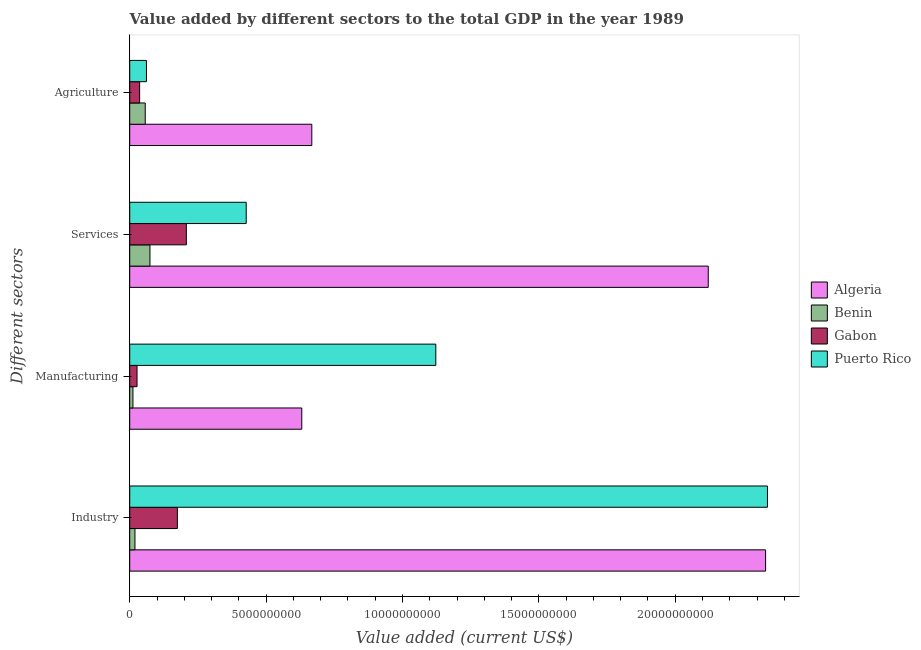How many groups of bars are there?
Your response must be concise. 4. Are the number of bars on each tick of the Y-axis equal?
Offer a terse response. Yes. How many bars are there on the 3rd tick from the top?
Your response must be concise. 4. How many bars are there on the 3rd tick from the bottom?
Keep it short and to the point. 4. What is the label of the 3rd group of bars from the top?
Make the answer very short. Manufacturing. What is the value added by manufacturing sector in Benin?
Make the answer very short. 1.18e+08. Across all countries, what is the maximum value added by industrial sector?
Give a very brief answer. 2.34e+1. Across all countries, what is the minimum value added by services sector?
Make the answer very short. 7.42e+08. In which country was the value added by manufacturing sector maximum?
Keep it short and to the point. Puerto Rico. In which country was the value added by services sector minimum?
Ensure brevity in your answer.  Benin. What is the total value added by manufacturing sector in the graph?
Ensure brevity in your answer.  1.79e+1. What is the difference between the value added by services sector in Algeria and that in Puerto Rico?
Offer a very short reply. 1.69e+1. What is the difference between the value added by manufacturing sector in Algeria and the value added by agricultural sector in Gabon?
Provide a succinct answer. 5.94e+09. What is the average value added by industrial sector per country?
Your answer should be compact. 1.22e+1. What is the difference between the value added by services sector and value added by manufacturing sector in Algeria?
Provide a succinct answer. 1.49e+1. What is the ratio of the value added by manufacturing sector in Puerto Rico to that in Benin?
Your response must be concise. 95.34. Is the value added by manufacturing sector in Puerto Rico less than that in Algeria?
Your answer should be very brief. No. What is the difference between the highest and the second highest value added by services sector?
Give a very brief answer. 1.69e+1. What is the difference between the highest and the lowest value added by services sector?
Keep it short and to the point. 2.05e+1. In how many countries, is the value added by agricultural sector greater than the average value added by agricultural sector taken over all countries?
Provide a short and direct response. 1. Is the sum of the value added by services sector in Algeria and Gabon greater than the maximum value added by agricultural sector across all countries?
Your response must be concise. Yes. What does the 3rd bar from the top in Services represents?
Your response must be concise. Benin. What does the 4th bar from the bottom in Industry represents?
Provide a succinct answer. Puerto Rico. Are all the bars in the graph horizontal?
Your answer should be very brief. Yes. How many countries are there in the graph?
Offer a very short reply. 4. What is the difference between two consecutive major ticks on the X-axis?
Your answer should be very brief. 5.00e+09. How are the legend labels stacked?
Your response must be concise. Vertical. What is the title of the graph?
Offer a very short reply. Value added by different sectors to the total GDP in the year 1989. Does "Finland" appear as one of the legend labels in the graph?
Offer a terse response. No. What is the label or title of the X-axis?
Ensure brevity in your answer.  Value added (current US$). What is the label or title of the Y-axis?
Your response must be concise. Different sectors. What is the Value added (current US$) of Algeria in Industry?
Provide a short and direct response. 2.33e+1. What is the Value added (current US$) in Benin in Industry?
Offer a terse response. 1.92e+08. What is the Value added (current US$) of Gabon in Industry?
Your response must be concise. 1.75e+09. What is the Value added (current US$) in Puerto Rico in Industry?
Offer a terse response. 2.34e+1. What is the Value added (current US$) in Algeria in Manufacturing?
Ensure brevity in your answer.  6.31e+09. What is the Value added (current US$) of Benin in Manufacturing?
Your response must be concise. 1.18e+08. What is the Value added (current US$) of Gabon in Manufacturing?
Offer a very short reply. 2.68e+08. What is the Value added (current US$) in Puerto Rico in Manufacturing?
Offer a terse response. 1.12e+1. What is the Value added (current US$) in Algeria in Services?
Your answer should be very brief. 2.12e+1. What is the Value added (current US$) in Benin in Services?
Offer a terse response. 7.42e+08. What is the Value added (current US$) in Gabon in Services?
Make the answer very short. 2.08e+09. What is the Value added (current US$) of Puerto Rico in Services?
Ensure brevity in your answer.  4.27e+09. What is the Value added (current US$) in Algeria in Agriculture?
Provide a succinct answer. 6.68e+09. What is the Value added (current US$) of Benin in Agriculture?
Offer a terse response. 5.69e+08. What is the Value added (current US$) in Gabon in Agriculture?
Your response must be concise. 3.64e+08. What is the Value added (current US$) of Puerto Rico in Agriculture?
Give a very brief answer. 6.13e+08. Across all Different sectors, what is the maximum Value added (current US$) of Algeria?
Keep it short and to the point. 2.33e+1. Across all Different sectors, what is the maximum Value added (current US$) of Benin?
Ensure brevity in your answer.  7.42e+08. Across all Different sectors, what is the maximum Value added (current US$) of Gabon?
Offer a very short reply. 2.08e+09. Across all Different sectors, what is the maximum Value added (current US$) of Puerto Rico?
Provide a succinct answer. 2.34e+1. Across all Different sectors, what is the minimum Value added (current US$) of Algeria?
Offer a terse response. 6.31e+09. Across all Different sectors, what is the minimum Value added (current US$) in Benin?
Give a very brief answer. 1.18e+08. Across all Different sectors, what is the minimum Value added (current US$) in Gabon?
Ensure brevity in your answer.  2.68e+08. Across all Different sectors, what is the minimum Value added (current US$) in Puerto Rico?
Offer a terse response. 6.13e+08. What is the total Value added (current US$) in Algeria in the graph?
Provide a succinct answer. 5.75e+1. What is the total Value added (current US$) in Benin in the graph?
Offer a terse response. 1.62e+09. What is the total Value added (current US$) of Gabon in the graph?
Offer a terse response. 4.45e+09. What is the total Value added (current US$) of Puerto Rico in the graph?
Keep it short and to the point. 3.95e+1. What is the difference between the Value added (current US$) of Algeria in Industry and that in Manufacturing?
Your response must be concise. 1.70e+1. What is the difference between the Value added (current US$) in Benin in Industry and that in Manufacturing?
Provide a succinct answer. 7.41e+07. What is the difference between the Value added (current US$) in Gabon in Industry and that in Manufacturing?
Offer a terse response. 1.48e+09. What is the difference between the Value added (current US$) of Puerto Rico in Industry and that in Manufacturing?
Provide a succinct answer. 1.22e+1. What is the difference between the Value added (current US$) in Algeria in Industry and that in Services?
Ensure brevity in your answer.  2.10e+09. What is the difference between the Value added (current US$) in Benin in Industry and that in Services?
Provide a short and direct response. -5.50e+08. What is the difference between the Value added (current US$) in Gabon in Industry and that in Services?
Give a very brief answer. -3.29e+08. What is the difference between the Value added (current US$) of Puerto Rico in Industry and that in Services?
Provide a succinct answer. 1.91e+1. What is the difference between the Value added (current US$) of Algeria in Industry and that in Agriculture?
Offer a terse response. 1.66e+1. What is the difference between the Value added (current US$) in Benin in Industry and that in Agriculture?
Offer a terse response. -3.77e+08. What is the difference between the Value added (current US$) in Gabon in Industry and that in Agriculture?
Give a very brief answer. 1.38e+09. What is the difference between the Value added (current US$) of Puerto Rico in Industry and that in Agriculture?
Give a very brief answer. 2.28e+1. What is the difference between the Value added (current US$) in Algeria in Manufacturing and that in Services?
Your answer should be very brief. -1.49e+1. What is the difference between the Value added (current US$) of Benin in Manufacturing and that in Services?
Provide a succinct answer. -6.24e+08. What is the difference between the Value added (current US$) in Gabon in Manufacturing and that in Services?
Your answer should be very brief. -1.81e+09. What is the difference between the Value added (current US$) in Puerto Rico in Manufacturing and that in Services?
Give a very brief answer. 6.95e+09. What is the difference between the Value added (current US$) of Algeria in Manufacturing and that in Agriculture?
Your answer should be very brief. -3.68e+08. What is the difference between the Value added (current US$) in Benin in Manufacturing and that in Agriculture?
Provide a succinct answer. -4.51e+08. What is the difference between the Value added (current US$) of Gabon in Manufacturing and that in Agriculture?
Provide a succinct answer. -9.56e+07. What is the difference between the Value added (current US$) of Puerto Rico in Manufacturing and that in Agriculture?
Ensure brevity in your answer.  1.06e+1. What is the difference between the Value added (current US$) of Algeria in Services and that in Agriculture?
Make the answer very short. 1.45e+1. What is the difference between the Value added (current US$) in Benin in Services and that in Agriculture?
Ensure brevity in your answer.  1.73e+08. What is the difference between the Value added (current US$) in Gabon in Services and that in Agriculture?
Offer a very short reply. 1.71e+09. What is the difference between the Value added (current US$) of Puerto Rico in Services and that in Agriculture?
Give a very brief answer. 3.66e+09. What is the difference between the Value added (current US$) of Algeria in Industry and the Value added (current US$) of Benin in Manufacturing?
Offer a terse response. 2.32e+1. What is the difference between the Value added (current US$) of Algeria in Industry and the Value added (current US$) of Gabon in Manufacturing?
Your answer should be very brief. 2.30e+1. What is the difference between the Value added (current US$) in Algeria in Industry and the Value added (current US$) in Puerto Rico in Manufacturing?
Keep it short and to the point. 1.21e+1. What is the difference between the Value added (current US$) of Benin in Industry and the Value added (current US$) of Gabon in Manufacturing?
Your answer should be compact. -7.62e+07. What is the difference between the Value added (current US$) of Benin in Industry and the Value added (current US$) of Puerto Rico in Manufacturing?
Your answer should be compact. -1.10e+1. What is the difference between the Value added (current US$) of Gabon in Industry and the Value added (current US$) of Puerto Rico in Manufacturing?
Offer a very short reply. -9.48e+09. What is the difference between the Value added (current US$) in Algeria in Industry and the Value added (current US$) in Benin in Services?
Ensure brevity in your answer.  2.26e+1. What is the difference between the Value added (current US$) of Algeria in Industry and the Value added (current US$) of Gabon in Services?
Provide a succinct answer. 2.12e+1. What is the difference between the Value added (current US$) of Algeria in Industry and the Value added (current US$) of Puerto Rico in Services?
Your response must be concise. 1.90e+1. What is the difference between the Value added (current US$) of Benin in Industry and the Value added (current US$) of Gabon in Services?
Your response must be concise. -1.88e+09. What is the difference between the Value added (current US$) of Benin in Industry and the Value added (current US$) of Puerto Rico in Services?
Give a very brief answer. -4.08e+09. What is the difference between the Value added (current US$) of Gabon in Industry and the Value added (current US$) of Puerto Rico in Services?
Make the answer very short. -2.52e+09. What is the difference between the Value added (current US$) in Algeria in Industry and the Value added (current US$) in Benin in Agriculture?
Offer a terse response. 2.27e+1. What is the difference between the Value added (current US$) of Algeria in Industry and the Value added (current US$) of Gabon in Agriculture?
Offer a very short reply. 2.30e+1. What is the difference between the Value added (current US$) of Algeria in Industry and the Value added (current US$) of Puerto Rico in Agriculture?
Offer a very short reply. 2.27e+1. What is the difference between the Value added (current US$) of Benin in Industry and the Value added (current US$) of Gabon in Agriculture?
Offer a very short reply. -1.72e+08. What is the difference between the Value added (current US$) in Benin in Industry and the Value added (current US$) in Puerto Rico in Agriculture?
Offer a terse response. -4.22e+08. What is the difference between the Value added (current US$) in Gabon in Industry and the Value added (current US$) in Puerto Rico in Agriculture?
Your answer should be compact. 1.13e+09. What is the difference between the Value added (current US$) of Algeria in Manufacturing and the Value added (current US$) of Benin in Services?
Your answer should be very brief. 5.57e+09. What is the difference between the Value added (current US$) of Algeria in Manufacturing and the Value added (current US$) of Gabon in Services?
Your answer should be compact. 4.23e+09. What is the difference between the Value added (current US$) in Algeria in Manufacturing and the Value added (current US$) in Puerto Rico in Services?
Ensure brevity in your answer.  2.04e+09. What is the difference between the Value added (current US$) of Benin in Manufacturing and the Value added (current US$) of Gabon in Services?
Your answer should be very brief. -1.96e+09. What is the difference between the Value added (current US$) in Benin in Manufacturing and the Value added (current US$) in Puerto Rico in Services?
Offer a very short reply. -4.15e+09. What is the difference between the Value added (current US$) in Gabon in Manufacturing and the Value added (current US$) in Puerto Rico in Services?
Provide a short and direct response. -4.00e+09. What is the difference between the Value added (current US$) in Algeria in Manufacturing and the Value added (current US$) in Benin in Agriculture?
Your response must be concise. 5.74e+09. What is the difference between the Value added (current US$) of Algeria in Manufacturing and the Value added (current US$) of Gabon in Agriculture?
Your response must be concise. 5.94e+09. What is the difference between the Value added (current US$) of Algeria in Manufacturing and the Value added (current US$) of Puerto Rico in Agriculture?
Your response must be concise. 5.69e+09. What is the difference between the Value added (current US$) of Benin in Manufacturing and the Value added (current US$) of Gabon in Agriculture?
Your response must be concise. -2.46e+08. What is the difference between the Value added (current US$) of Benin in Manufacturing and the Value added (current US$) of Puerto Rico in Agriculture?
Offer a very short reply. -4.96e+08. What is the difference between the Value added (current US$) of Gabon in Manufacturing and the Value added (current US$) of Puerto Rico in Agriculture?
Provide a succinct answer. -3.45e+08. What is the difference between the Value added (current US$) of Algeria in Services and the Value added (current US$) of Benin in Agriculture?
Your answer should be compact. 2.06e+1. What is the difference between the Value added (current US$) in Algeria in Services and the Value added (current US$) in Gabon in Agriculture?
Your response must be concise. 2.08e+1. What is the difference between the Value added (current US$) in Algeria in Services and the Value added (current US$) in Puerto Rico in Agriculture?
Provide a succinct answer. 2.06e+1. What is the difference between the Value added (current US$) of Benin in Services and the Value added (current US$) of Gabon in Agriculture?
Offer a terse response. 3.78e+08. What is the difference between the Value added (current US$) in Benin in Services and the Value added (current US$) in Puerto Rico in Agriculture?
Your response must be concise. 1.28e+08. What is the difference between the Value added (current US$) in Gabon in Services and the Value added (current US$) in Puerto Rico in Agriculture?
Offer a very short reply. 1.46e+09. What is the average Value added (current US$) in Algeria per Different sectors?
Offer a terse response. 1.44e+1. What is the average Value added (current US$) in Benin per Different sectors?
Give a very brief answer. 4.05e+08. What is the average Value added (current US$) of Gabon per Different sectors?
Make the answer very short. 1.11e+09. What is the average Value added (current US$) in Puerto Rico per Different sectors?
Give a very brief answer. 9.87e+09. What is the difference between the Value added (current US$) of Algeria and Value added (current US$) of Benin in Industry?
Keep it short and to the point. 2.31e+1. What is the difference between the Value added (current US$) of Algeria and Value added (current US$) of Gabon in Industry?
Give a very brief answer. 2.16e+1. What is the difference between the Value added (current US$) in Algeria and Value added (current US$) in Puerto Rico in Industry?
Offer a terse response. -6.80e+07. What is the difference between the Value added (current US$) of Benin and Value added (current US$) of Gabon in Industry?
Provide a succinct answer. -1.56e+09. What is the difference between the Value added (current US$) in Benin and Value added (current US$) in Puerto Rico in Industry?
Your answer should be compact. -2.32e+1. What is the difference between the Value added (current US$) in Gabon and Value added (current US$) in Puerto Rico in Industry?
Offer a very short reply. -2.16e+1. What is the difference between the Value added (current US$) of Algeria and Value added (current US$) of Benin in Manufacturing?
Your answer should be compact. 6.19e+09. What is the difference between the Value added (current US$) of Algeria and Value added (current US$) of Gabon in Manufacturing?
Offer a terse response. 6.04e+09. What is the difference between the Value added (current US$) of Algeria and Value added (current US$) of Puerto Rico in Manufacturing?
Offer a terse response. -4.91e+09. What is the difference between the Value added (current US$) of Benin and Value added (current US$) of Gabon in Manufacturing?
Provide a succinct answer. -1.50e+08. What is the difference between the Value added (current US$) of Benin and Value added (current US$) of Puerto Rico in Manufacturing?
Your answer should be compact. -1.11e+1. What is the difference between the Value added (current US$) in Gabon and Value added (current US$) in Puerto Rico in Manufacturing?
Give a very brief answer. -1.10e+1. What is the difference between the Value added (current US$) in Algeria and Value added (current US$) in Benin in Services?
Your response must be concise. 2.05e+1. What is the difference between the Value added (current US$) of Algeria and Value added (current US$) of Gabon in Services?
Give a very brief answer. 1.91e+1. What is the difference between the Value added (current US$) of Algeria and Value added (current US$) of Puerto Rico in Services?
Your response must be concise. 1.69e+1. What is the difference between the Value added (current US$) of Benin and Value added (current US$) of Gabon in Services?
Provide a succinct answer. -1.33e+09. What is the difference between the Value added (current US$) of Benin and Value added (current US$) of Puerto Rico in Services?
Make the answer very short. -3.53e+09. What is the difference between the Value added (current US$) of Gabon and Value added (current US$) of Puerto Rico in Services?
Offer a very short reply. -2.20e+09. What is the difference between the Value added (current US$) of Algeria and Value added (current US$) of Benin in Agriculture?
Your answer should be very brief. 6.11e+09. What is the difference between the Value added (current US$) of Algeria and Value added (current US$) of Gabon in Agriculture?
Ensure brevity in your answer.  6.31e+09. What is the difference between the Value added (current US$) of Algeria and Value added (current US$) of Puerto Rico in Agriculture?
Provide a short and direct response. 6.06e+09. What is the difference between the Value added (current US$) in Benin and Value added (current US$) in Gabon in Agriculture?
Make the answer very short. 2.05e+08. What is the difference between the Value added (current US$) in Benin and Value added (current US$) in Puerto Rico in Agriculture?
Make the answer very short. -4.47e+07. What is the difference between the Value added (current US$) of Gabon and Value added (current US$) of Puerto Rico in Agriculture?
Your response must be concise. -2.50e+08. What is the ratio of the Value added (current US$) in Algeria in Industry to that in Manufacturing?
Your answer should be very brief. 3.7. What is the ratio of the Value added (current US$) of Benin in Industry to that in Manufacturing?
Offer a terse response. 1.63. What is the ratio of the Value added (current US$) of Gabon in Industry to that in Manufacturing?
Make the answer very short. 6.52. What is the ratio of the Value added (current US$) of Puerto Rico in Industry to that in Manufacturing?
Ensure brevity in your answer.  2.08. What is the ratio of the Value added (current US$) of Algeria in Industry to that in Services?
Make the answer very short. 1.1. What is the ratio of the Value added (current US$) in Benin in Industry to that in Services?
Provide a succinct answer. 0.26. What is the ratio of the Value added (current US$) of Gabon in Industry to that in Services?
Provide a succinct answer. 0.84. What is the ratio of the Value added (current US$) of Puerto Rico in Industry to that in Services?
Give a very brief answer. 5.47. What is the ratio of the Value added (current US$) in Algeria in Industry to that in Agriculture?
Offer a very short reply. 3.49. What is the ratio of the Value added (current US$) in Benin in Industry to that in Agriculture?
Provide a short and direct response. 0.34. What is the ratio of the Value added (current US$) of Gabon in Industry to that in Agriculture?
Give a very brief answer. 4.8. What is the ratio of the Value added (current US$) of Puerto Rico in Industry to that in Agriculture?
Make the answer very short. 38.12. What is the ratio of the Value added (current US$) of Algeria in Manufacturing to that in Services?
Ensure brevity in your answer.  0.3. What is the ratio of the Value added (current US$) of Benin in Manufacturing to that in Services?
Ensure brevity in your answer.  0.16. What is the ratio of the Value added (current US$) of Gabon in Manufacturing to that in Services?
Provide a succinct answer. 0.13. What is the ratio of the Value added (current US$) of Puerto Rico in Manufacturing to that in Services?
Give a very brief answer. 2.63. What is the ratio of the Value added (current US$) of Algeria in Manufacturing to that in Agriculture?
Keep it short and to the point. 0.94. What is the ratio of the Value added (current US$) of Benin in Manufacturing to that in Agriculture?
Your answer should be compact. 0.21. What is the ratio of the Value added (current US$) in Gabon in Manufacturing to that in Agriculture?
Ensure brevity in your answer.  0.74. What is the ratio of the Value added (current US$) of Puerto Rico in Manufacturing to that in Agriculture?
Give a very brief answer. 18.29. What is the ratio of the Value added (current US$) of Algeria in Services to that in Agriculture?
Offer a terse response. 3.18. What is the ratio of the Value added (current US$) in Benin in Services to that in Agriculture?
Ensure brevity in your answer.  1.3. What is the ratio of the Value added (current US$) of Gabon in Services to that in Agriculture?
Keep it short and to the point. 5.71. What is the ratio of the Value added (current US$) of Puerto Rico in Services to that in Agriculture?
Your answer should be compact. 6.96. What is the difference between the highest and the second highest Value added (current US$) in Algeria?
Your response must be concise. 2.10e+09. What is the difference between the highest and the second highest Value added (current US$) in Benin?
Provide a succinct answer. 1.73e+08. What is the difference between the highest and the second highest Value added (current US$) in Gabon?
Provide a succinct answer. 3.29e+08. What is the difference between the highest and the second highest Value added (current US$) in Puerto Rico?
Offer a terse response. 1.22e+1. What is the difference between the highest and the lowest Value added (current US$) of Algeria?
Provide a short and direct response. 1.70e+1. What is the difference between the highest and the lowest Value added (current US$) of Benin?
Offer a terse response. 6.24e+08. What is the difference between the highest and the lowest Value added (current US$) in Gabon?
Offer a terse response. 1.81e+09. What is the difference between the highest and the lowest Value added (current US$) in Puerto Rico?
Provide a succinct answer. 2.28e+1. 